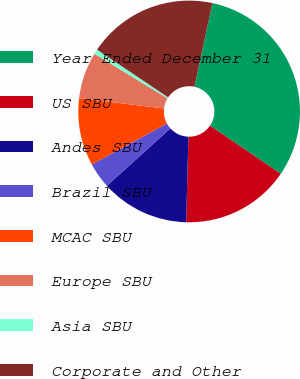Convert chart. <chart><loc_0><loc_0><loc_500><loc_500><pie_chart><fcel>Year Ended December 31<fcel>US SBU<fcel>Andes SBU<fcel>Brazil SBU<fcel>MCAC SBU<fcel>Europe SBU<fcel>Asia SBU<fcel>Corporate and Other<nl><fcel>31.13%<fcel>15.92%<fcel>12.88%<fcel>3.75%<fcel>9.84%<fcel>6.8%<fcel>0.71%<fcel>18.96%<nl></chart> 